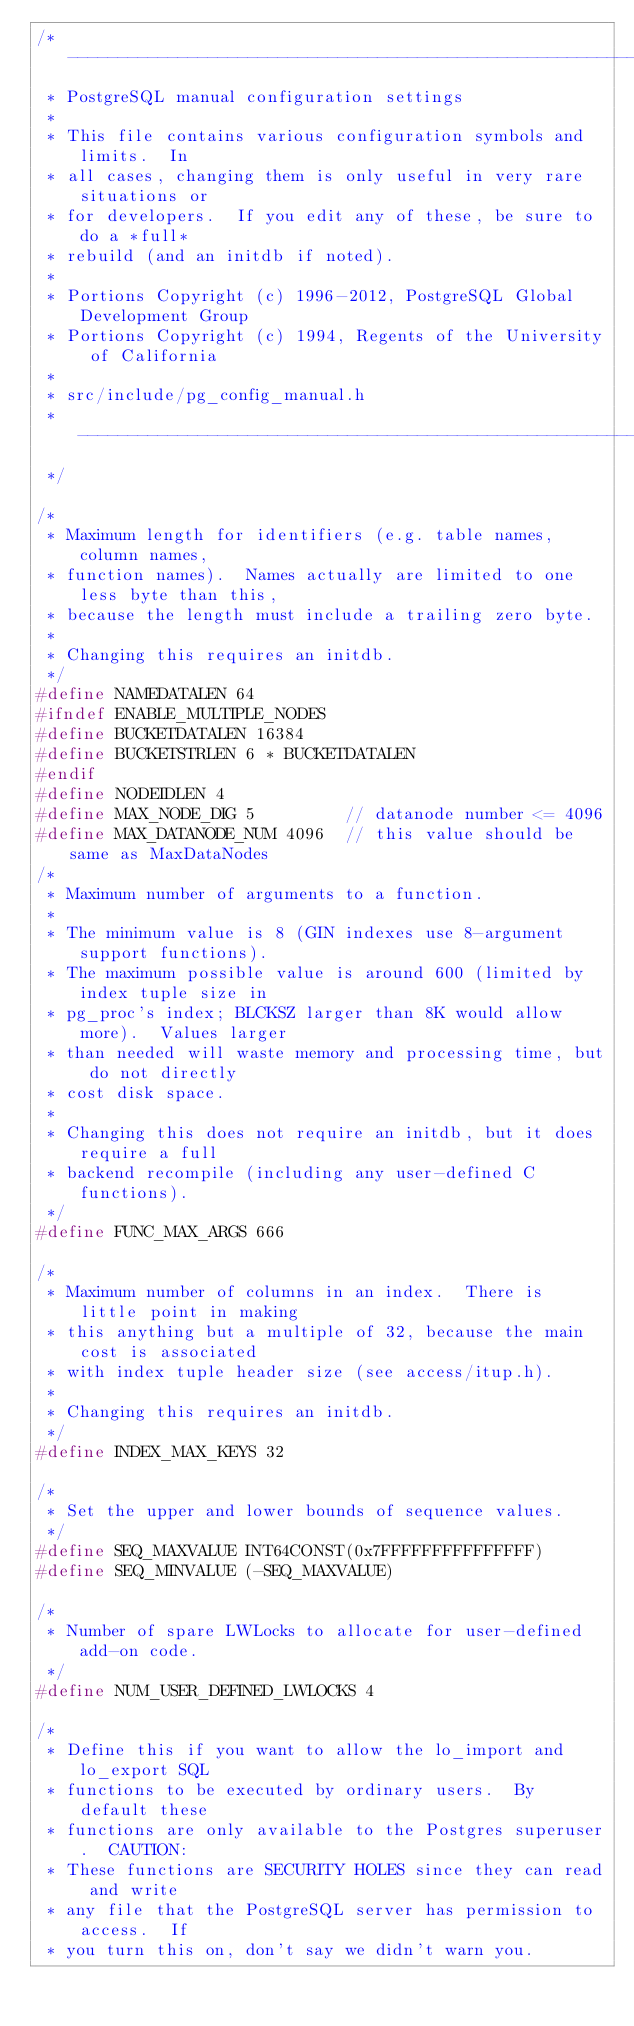Convert code to text. <code><loc_0><loc_0><loc_500><loc_500><_C_>/* ------------------------------------------------------------------------
 * PostgreSQL manual configuration settings
 *
 * This file contains various configuration symbols and limits.  In
 * all cases, changing them is only useful in very rare situations or
 * for developers.	If you edit any of these, be sure to do a *full*
 * rebuild (and an initdb if noted).
 *
 * Portions Copyright (c) 1996-2012, PostgreSQL Global Development Group
 * Portions Copyright (c) 1994, Regents of the University of California
 *
 * src/include/pg_config_manual.h
 * ------------------------------------------------------------------------
 */

/*
 * Maximum length for identifiers (e.g. table names, column names,
 * function names).  Names actually are limited to one less byte than this,
 * because the length must include a trailing zero byte.
 *
 * Changing this requires an initdb.
 */
#define NAMEDATALEN 64
#ifndef ENABLE_MULTIPLE_NODES
#define BUCKETDATALEN 16384
#define BUCKETSTRLEN 6 * BUCKETDATALEN
#endif
#define NODEIDLEN 4
#define MAX_NODE_DIG 5         // datanode number <= 4096
#define MAX_DATANODE_NUM 4096  // this value should be same as MaxDataNodes
/*
 * Maximum number of arguments to a function.
 *
 * The minimum value is 8 (GIN indexes use 8-argument support functions).
 * The maximum possible value is around 600 (limited by index tuple size in
 * pg_proc's index; BLCKSZ larger than 8K would allow more).  Values larger
 * than needed will waste memory and processing time, but do not directly
 * cost disk space.
 *
 * Changing this does not require an initdb, but it does require a full
 * backend recompile (including any user-defined C functions).
 */
#define FUNC_MAX_ARGS 666

/*
 * Maximum number of columns in an index.  There is little point in making
 * this anything but a multiple of 32, because the main cost is associated
 * with index tuple header size (see access/itup.h).
 *
 * Changing this requires an initdb.
 */
#define INDEX_MAX_KEYS 32

/*
 * Set the upper and lower bounds of sequence values.
 */
#define SEQ_MAXVALUE INT64CONST(0x7FFFFFFFFFFFFFFF)
#define SEQ_MINVALUE (-SEQ_MAXVALUE)

/*
 * Number of spare LWLocks to allocate for user-defined add-on code.
 */
#define NUM_USER_DEFINED_LWLOCKS 4

/*
 * Define this if you want to allow the lo_import and lo_export SQL
 * functions to be executed by ordinary users.	By default these
 * functions are only available to the Postgres superuser.	CAUTION:
 * These functions are SECURITY HOLES since they can read and write
 * any file that the PostgreSQL server has permission to access.  If
 * you turn this on, don't say we didn't warn you.</code> 